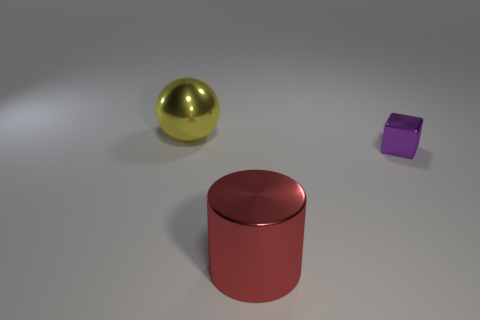What number of small purple cubes are there?
Offer a terse response. 1. Do the big red metallic thing and the metal thing behind the purple thing have the same shape?
Keep it short and to the point. No. How many objects are purple metallic things or big objects that are behind the small block?
Your answer should be very brief. 2. Is the shape of the large shiny object that is in front of the small purple cube the same as  the small thing?
Keep it short and to the point. No. Are there any other things that have the same size as the cube?
Ensure brevity in your answer.  No. Are there fewer large red objects that are left of the shiny ball than tiny shiny things that are on the right side of the large red object?
Keep it short and to the point. Yes. How many other objects are the same shape as the purple metal object?
Your answer should be very brief. 0. What is the size of the shiny thing behind the thing that is right of the big metal object on the right side of the big sphere?
Offer a terse response. Large. What number of yellow things are metallic things or large cylinders?
Make the answer very short. 1. What shape is the shiny object that is in front of the tiny purple metallic block right of the shiny cylinder?
Make the answer very short. Cylinder. 